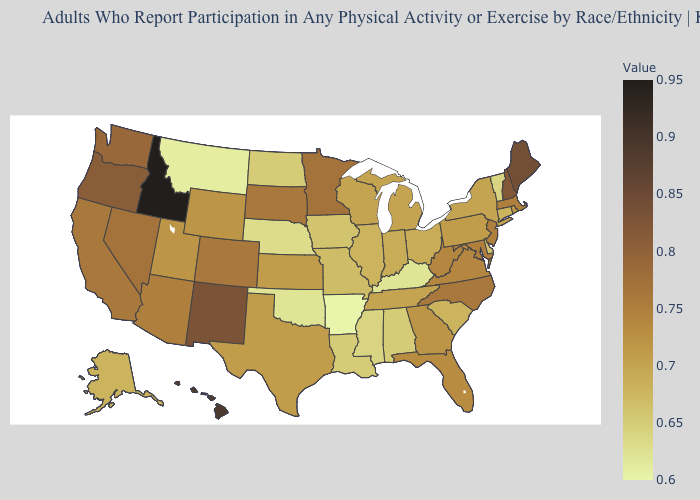Which states have the highest value in the USA?
Answer briefly. Idaho. Does Mississippi have a higher value than Arkansas?
Short answer required. Yes. Which states have the lowest value in the USA?
Write a very short answer. Arkansas. Does Virginia have a higher value than Arkansas?
Quick response, please. Yes. Does Pennsylvania have a higher value than Louisiana?
Keep it brief. Yes. 